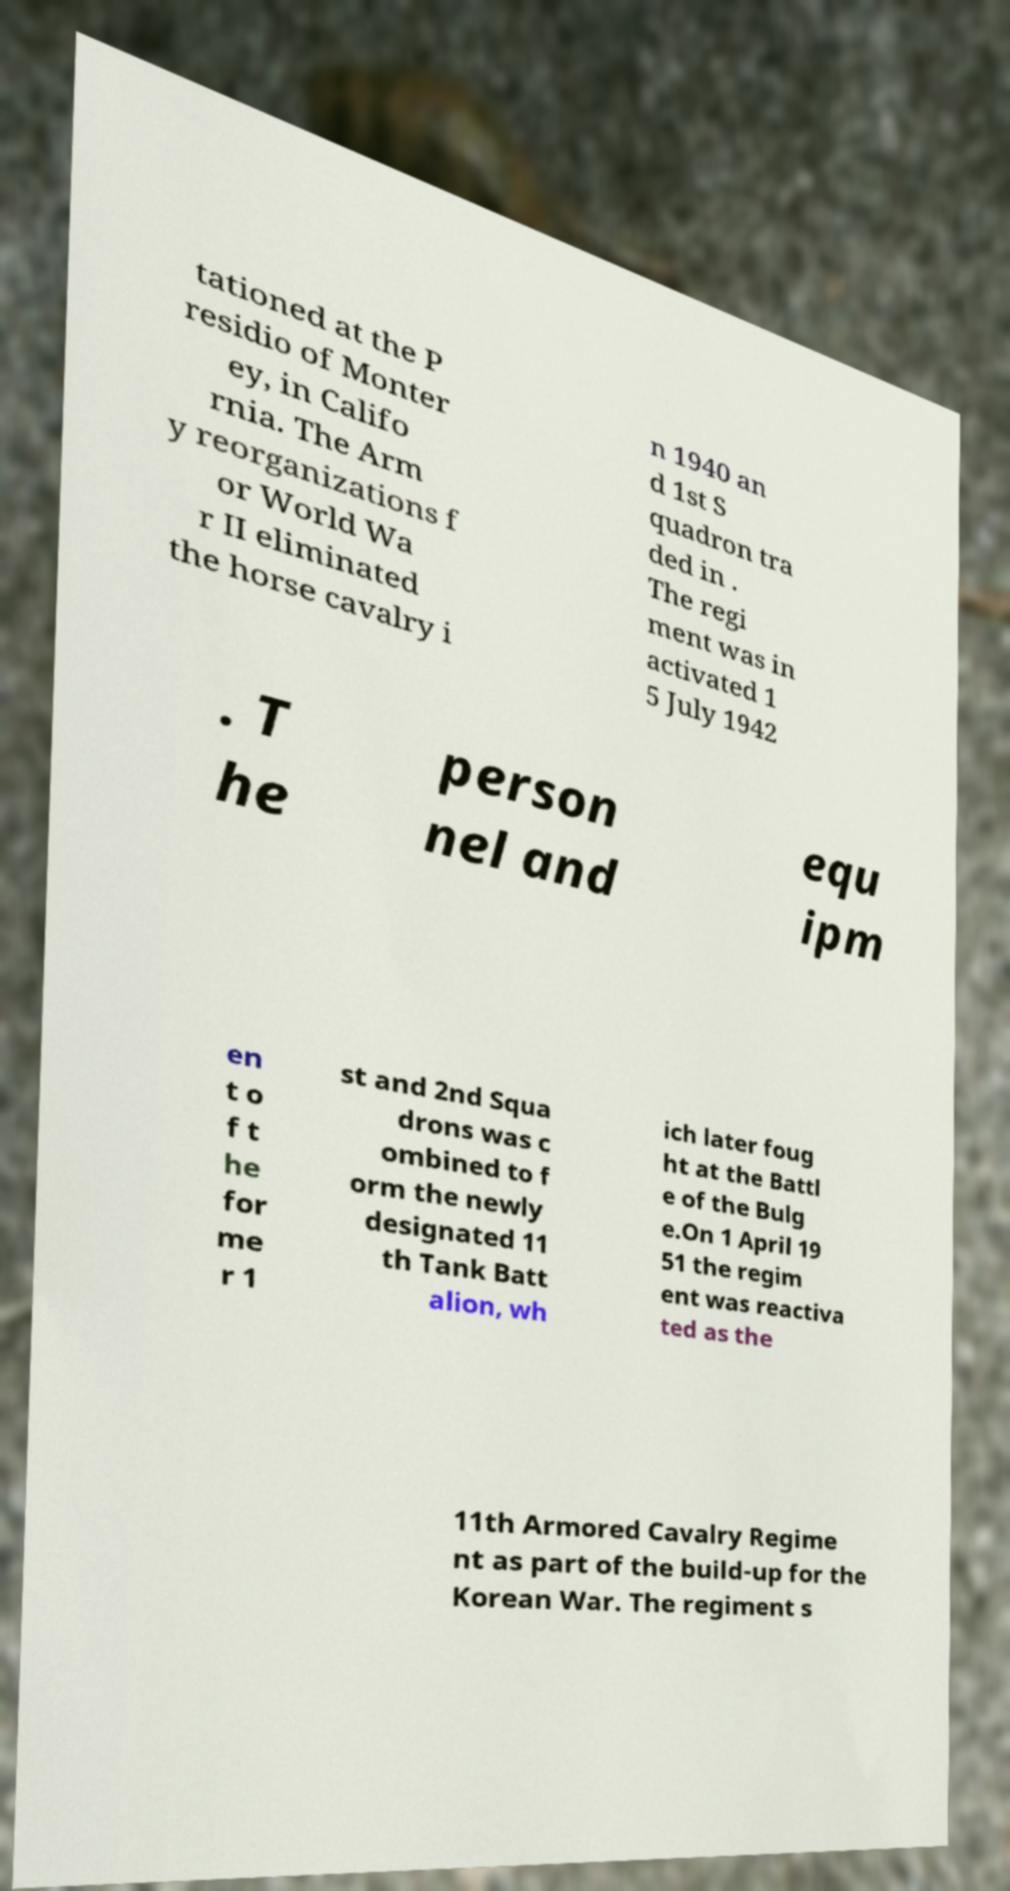Please identify and transcribe the text found in this image. tationed at the P residio of Monter ey, in Califo rnia. The Arm y reorganizations f or World Wa r II eliminated the horse cavalry i n 1940 an d 1st S quadron tra ded in . The regi ment was in activated 1 5 July 1942 . T he person nel and equ ipm en t o f t he for me r 1 st and 2nd Squa drons was c ombined to f orm the newly designated 11 th Tank Batt alion, wh ich later foug ht at the Battl e of the Bulg e.On 1 April 19 51 the regim ent was reactiva ted as the 11th Armored Cavalry Regime nt as part of the build-up for the Korean War. The regiment s 